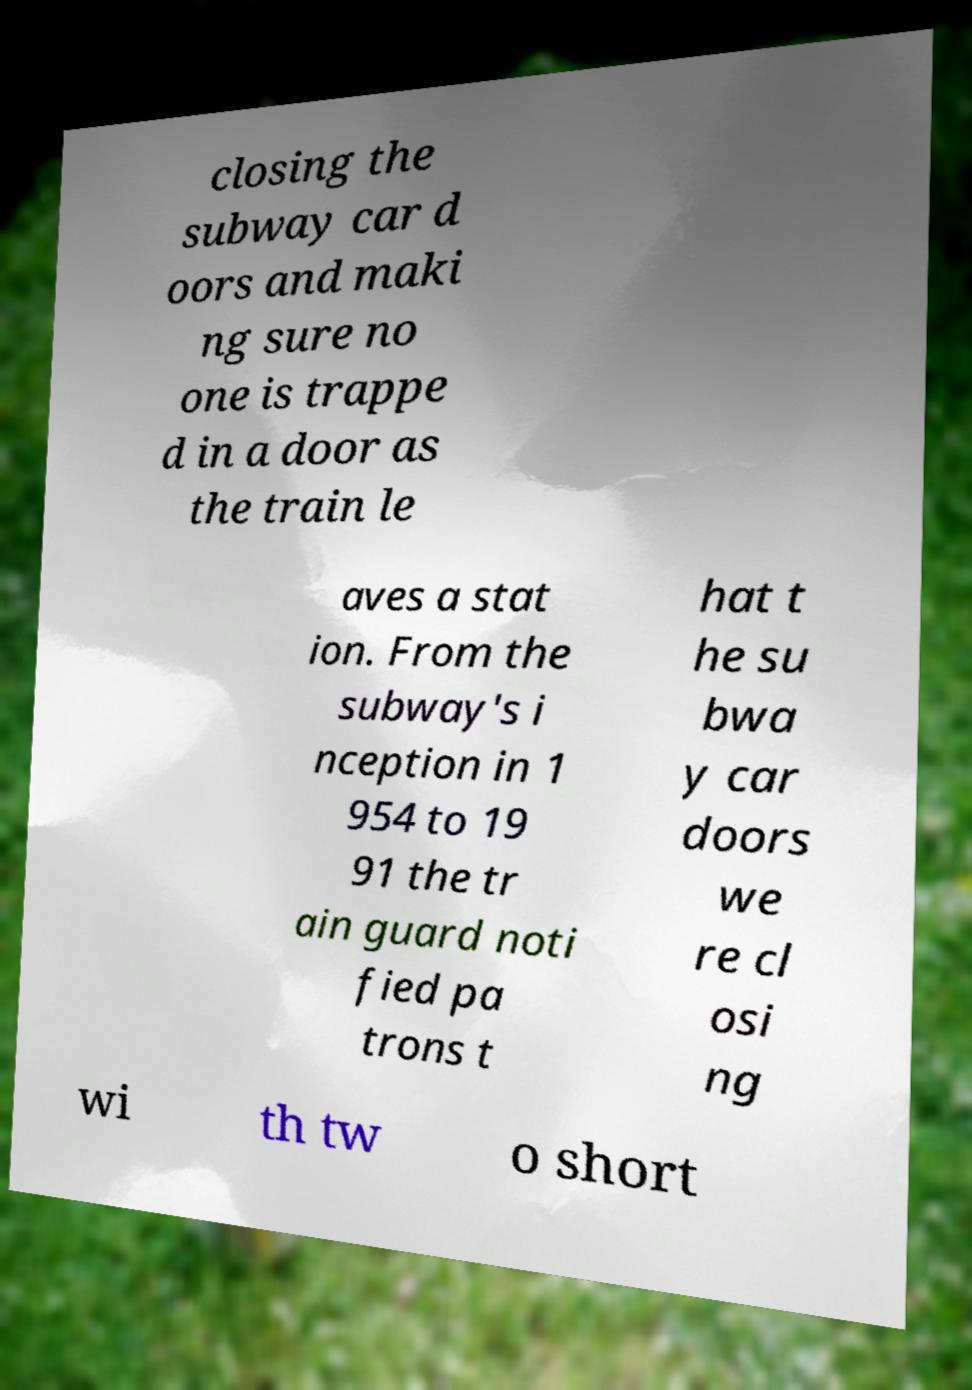What messages or text are displayed in this image? I need them in a readable, typed format. closing the subway car d oors and maki ng sure no one is trappe d in a door as the train le aves a stat ion. From the subway's i nception in 1 954 to 19 91 the tr ain guard noti fied pa trons t hat t he su bwa y car doors we re cl osi ng wi th tw o short 